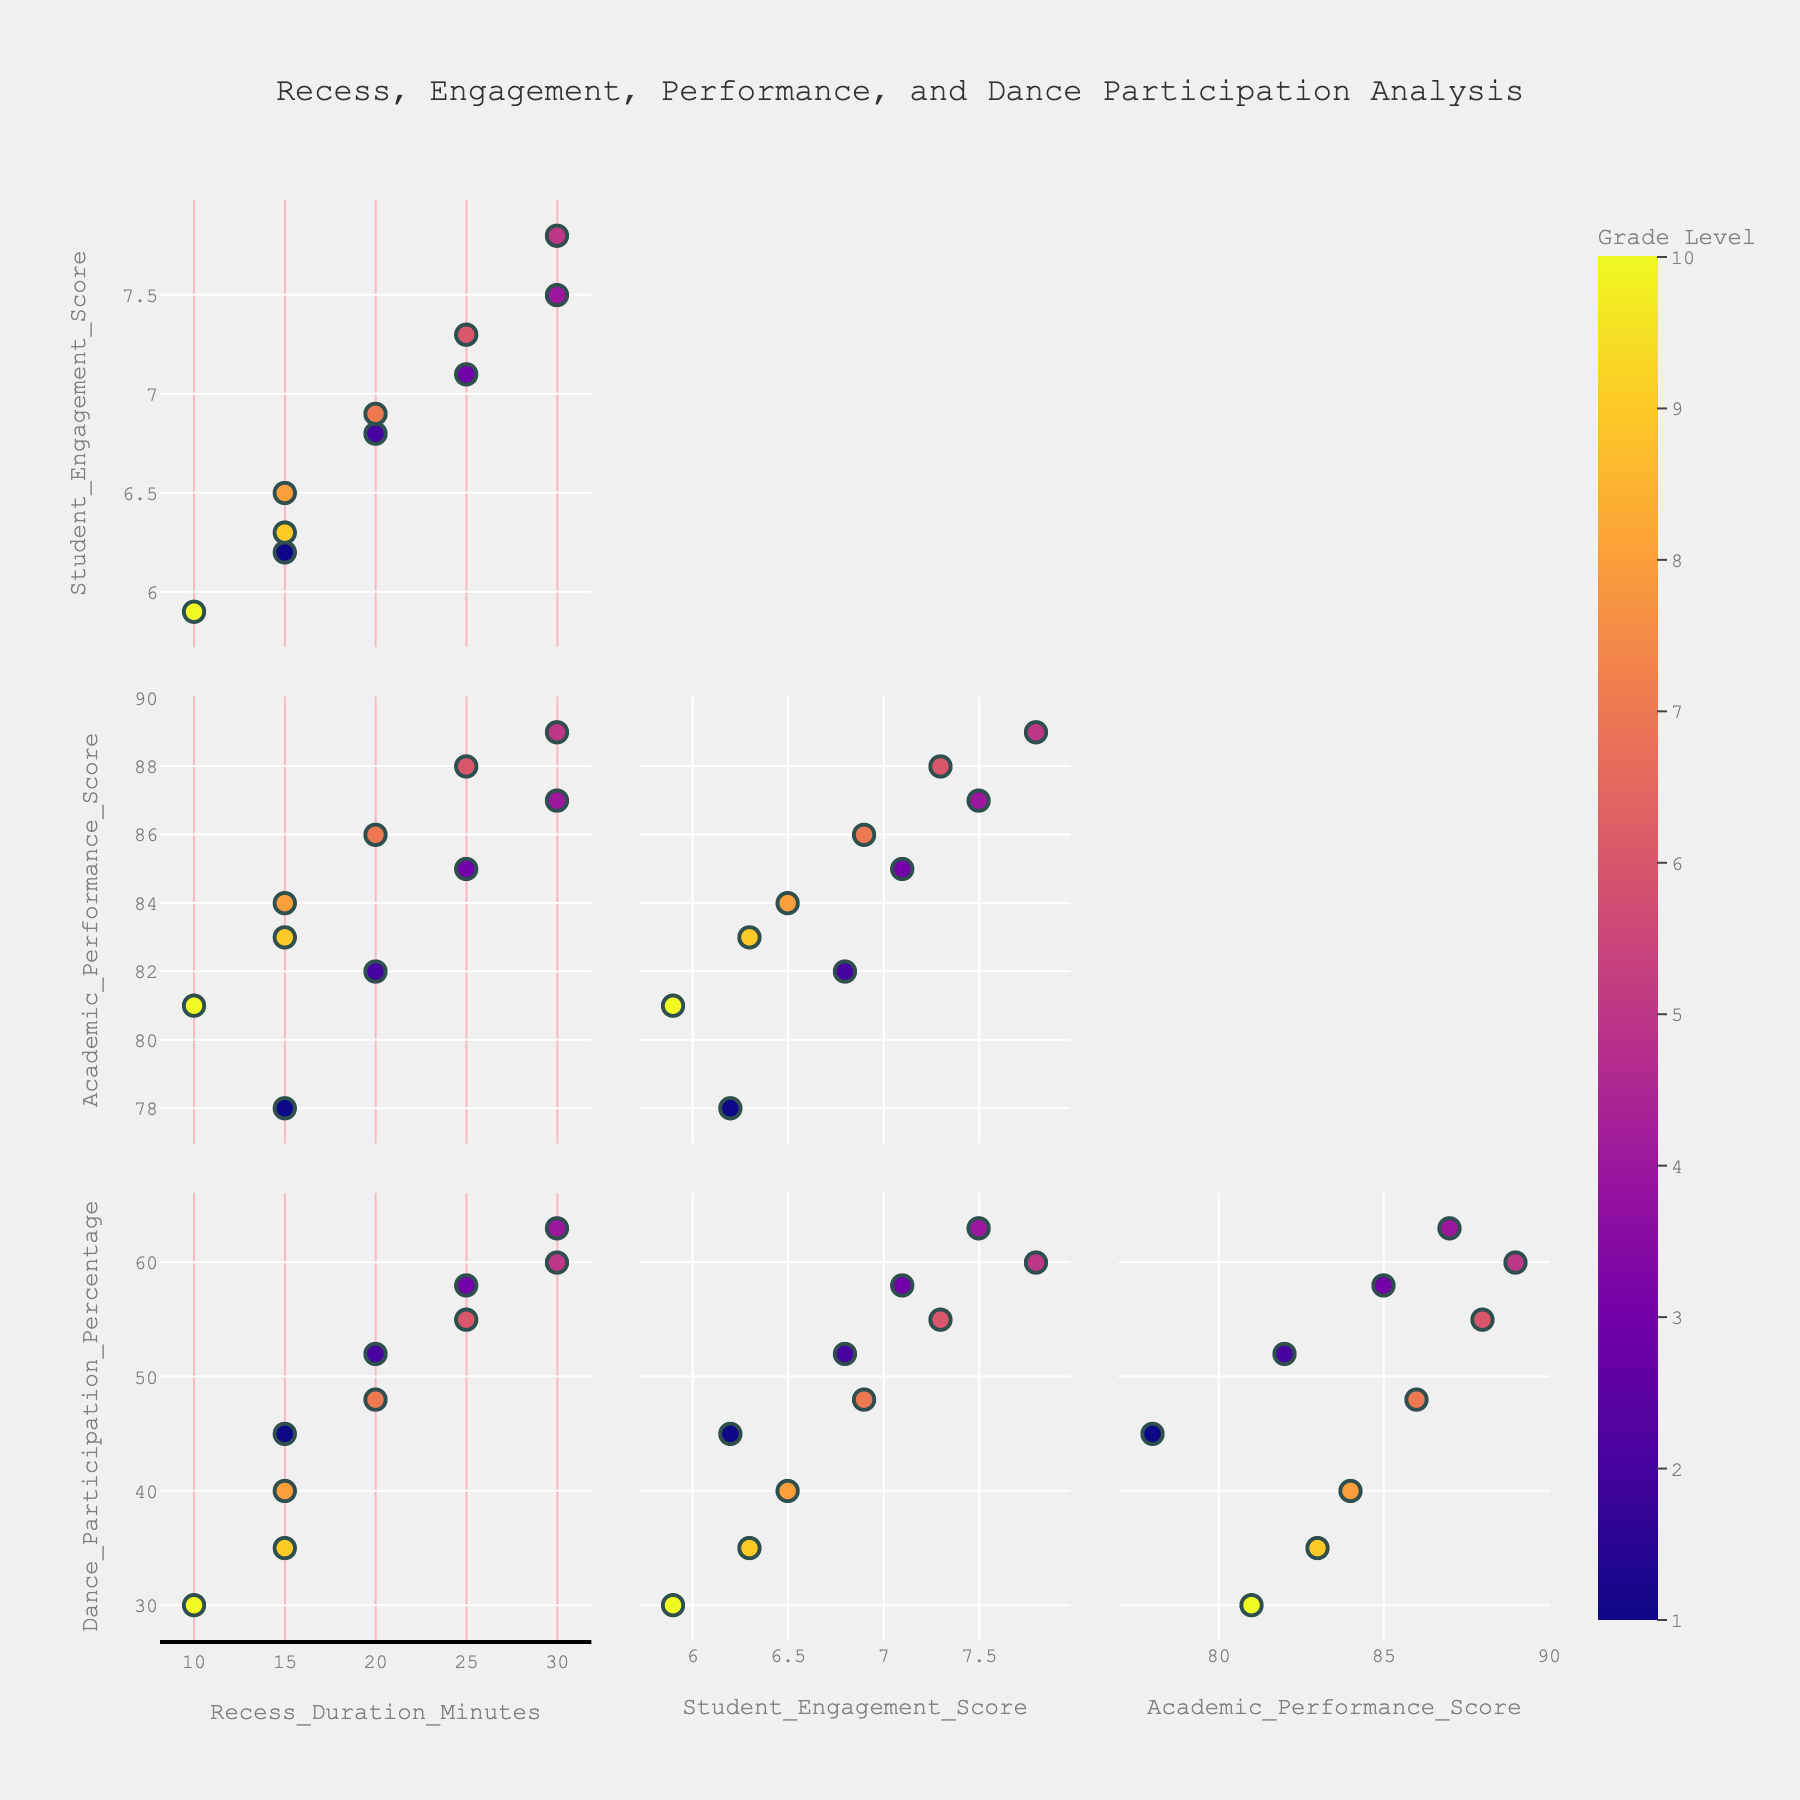What's the title of the figure? The title of the figure is typically placed at the top and it provides a summary of what the scatterplot matrix represents. We can read the title directly from this position.
Answer: Recess, Engagement, Performance, and Dance Participation Analysis How many dimensions are displayed in the scatterplot matrix? By examining the axes and labels, we can count the distinct dimensions or variables represented in the scatterplot matrix.
Answer: Four Which grade level exhibits the highest academic performance score? By looking at the scatterplot involving the Grade_Level and Academic_Performance_Score, we can identify the highest value on the academic performance axis and note the corresponding grade level.
Answer: Grade 6 How does student engagement score correlate with recess duration? To determine the correlation nature, we can analyze the scatterplot involving Student_Engagement_Score and Recess_Duration_Minutes by observing the plot's overall direction or pattern, whether it is positive, negative, or no correlation.
Answer: Positive correlation Which combination of grades shows the largest difference in dance participation percentage? By comparing the Dance_Participation_Percentage across different Grade_Levels, we identify the pair of grades with the maximum difference in values. For more precision, look at the extreme values within the scatterplot or table.
Answer: Grades 1 and 10 Are there more data points with recess duration of 15 minutes or 30 minutes? Count the number of data points at the specific x-axis values (15 and 30 minutes) in the scatterplot matrix involving Recess_Duration_Minutes.
Answer: 15 minutes What is the average student engagement score for the grades listed? Add all the Student_Engagement_Score values given in the data and then divide by the number of grades to find the average.
Answer: \( (6.2 + 6.8 + 7.1 + 7.5 + 7.8 + 7.3 + 6.9 + 6.5 + 6.3 + 5.9) / 10 = 6.83 \) Which grade has the lowest dance participation percentage, and what is the score? By examining the scatterplot involving Grade_Level and Dance_Participation_Percentage, identify the lowest point and its corresponding grade level.
Answer: Grade 10 with 30% How does academic performance vary with changes in recess duration? Analyze the scatterplot involving Academic_Performance_Score and Recess_Duration_Minutes to observe the pattern of points and determine the trend or variation.
Answer: Generally increases with longer recess Comparing grade 5 and grade 9, which grade exhibits higher average student engagement score? Look at the specific data points or scatterplots showing Student_Engagement_Score for grades 5 and 9, and directly compare their values.
Answer: Grade 5 